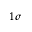<formula> <loc_0><loc_0><loc_500><loc_500>1 \sigma</formula> 